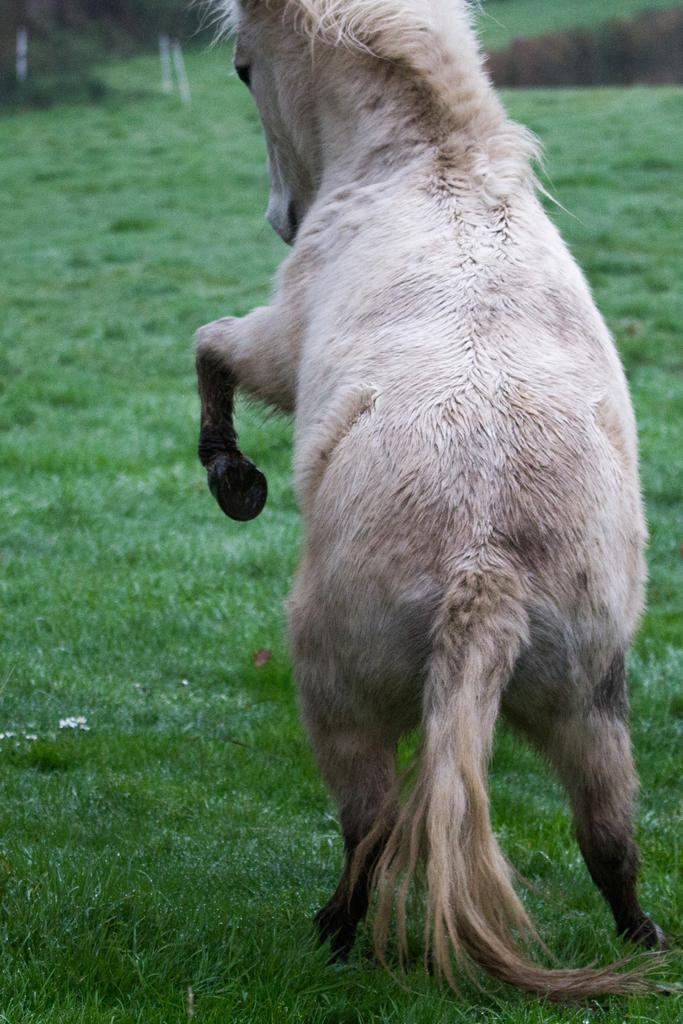What is the main subject of the image? There is a horse in the center of the image. What can be seen in the background of the image? There is grass in the background of the image. What type of chalk is the horse using to draw in the image? There is no chalk or drawing activity present in the image; it features a horse and grass in the background. 